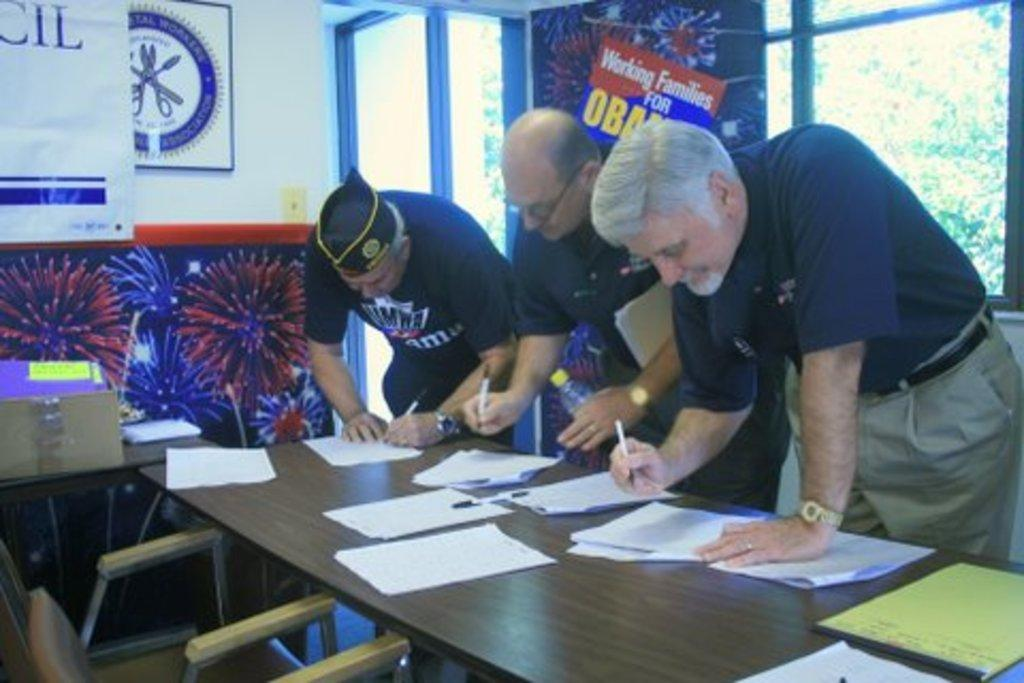How many people are in the image? There are three people in the image. Where are the people located in the image? The people are standing on the right side. What are the people doing in the image? The people appear to be writing on a paper. Where is the paper located in the image? The paper is on a table. What type of harmony is being played by the people in the image? There is no indication of music or harmony in the image; the people are writing on a paper. 